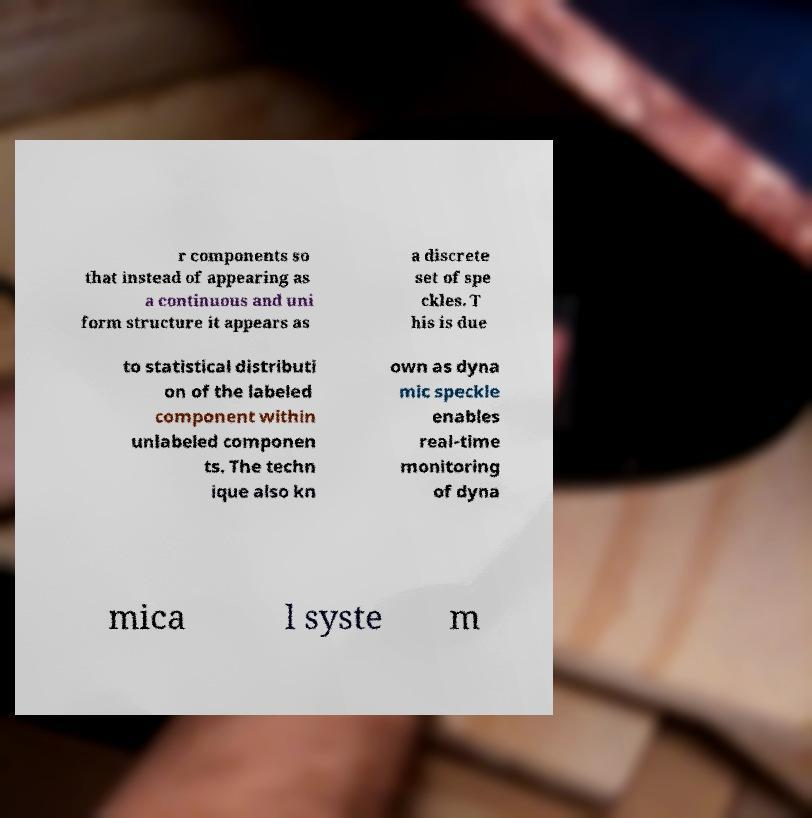Could you extract and type out the text from this image? r components so that instead of appearing as a continuous and uni form structure it appears as a discrete set of spe ckles. T his is due to statistical distributi on of the labeled component within unlabeled componen ts. The techn ique also kn own as dyna mic speckle enables real-time monitoring of dyna mica l syste m 